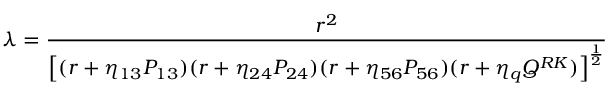<formula> <loc_0><loc_0><loc_500><loc_500>{ \lambda = { \frac { r ^ { 2 } } { \left [ ( r + \eta _ { 1 3 } P _ { 1 3 } ) ( r + \eta _ { 2 4 } P _ { 2 4 } ) ( r + \eta _ { 5 6 } P _ { 5 6 } ) ( r + \eta _ { q } Q ^ { R K } ) \right ] ^ { \frac { 1 } { 2 } } } } }</formula> 